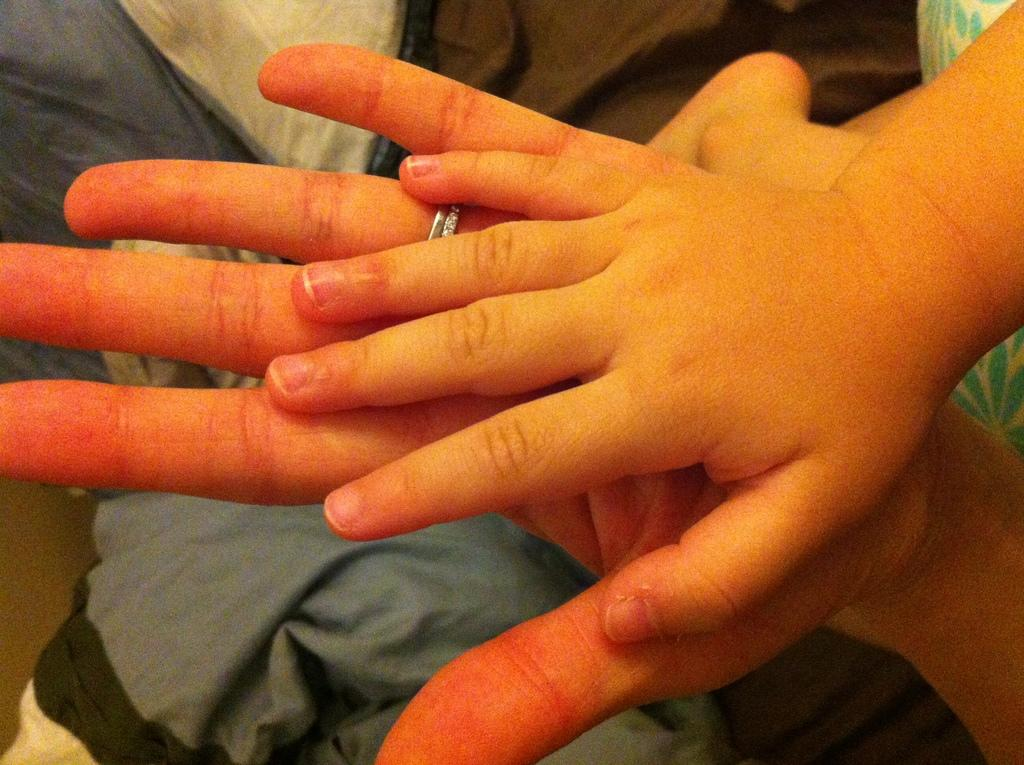What can be seen in the image related to human body parts? There are hands of persons visible in the image. What else can be seen in the image besides the hands? There are clothes visible in the image. How many leaves can be seen on the apple in the image? There is no apple or leaf present in the image. What type of ants can be seen crawling on the clothes in the image? There are no ants visible in the image. 